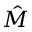Convert formula to latex. <formula><loc_0><loc_0><loc_500><loc_500>\hat { M }</formula> 